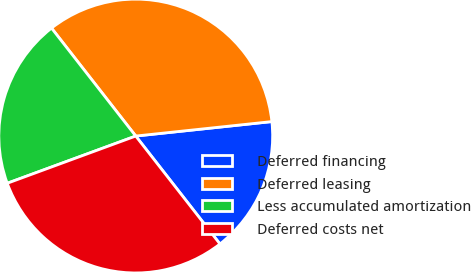Convert chart. <chart><loc_0><loc_0><loc_500><loc_500><pie_chart><fcel>Deferred financing<fcel>Deferred leasing<fcel>Less accumulated amortization<fcel>Deferred costs net<nl><fcel>16.14%<fcel>33.86%<fcel>20.06%<fcel>29.94%<nl></chart> 